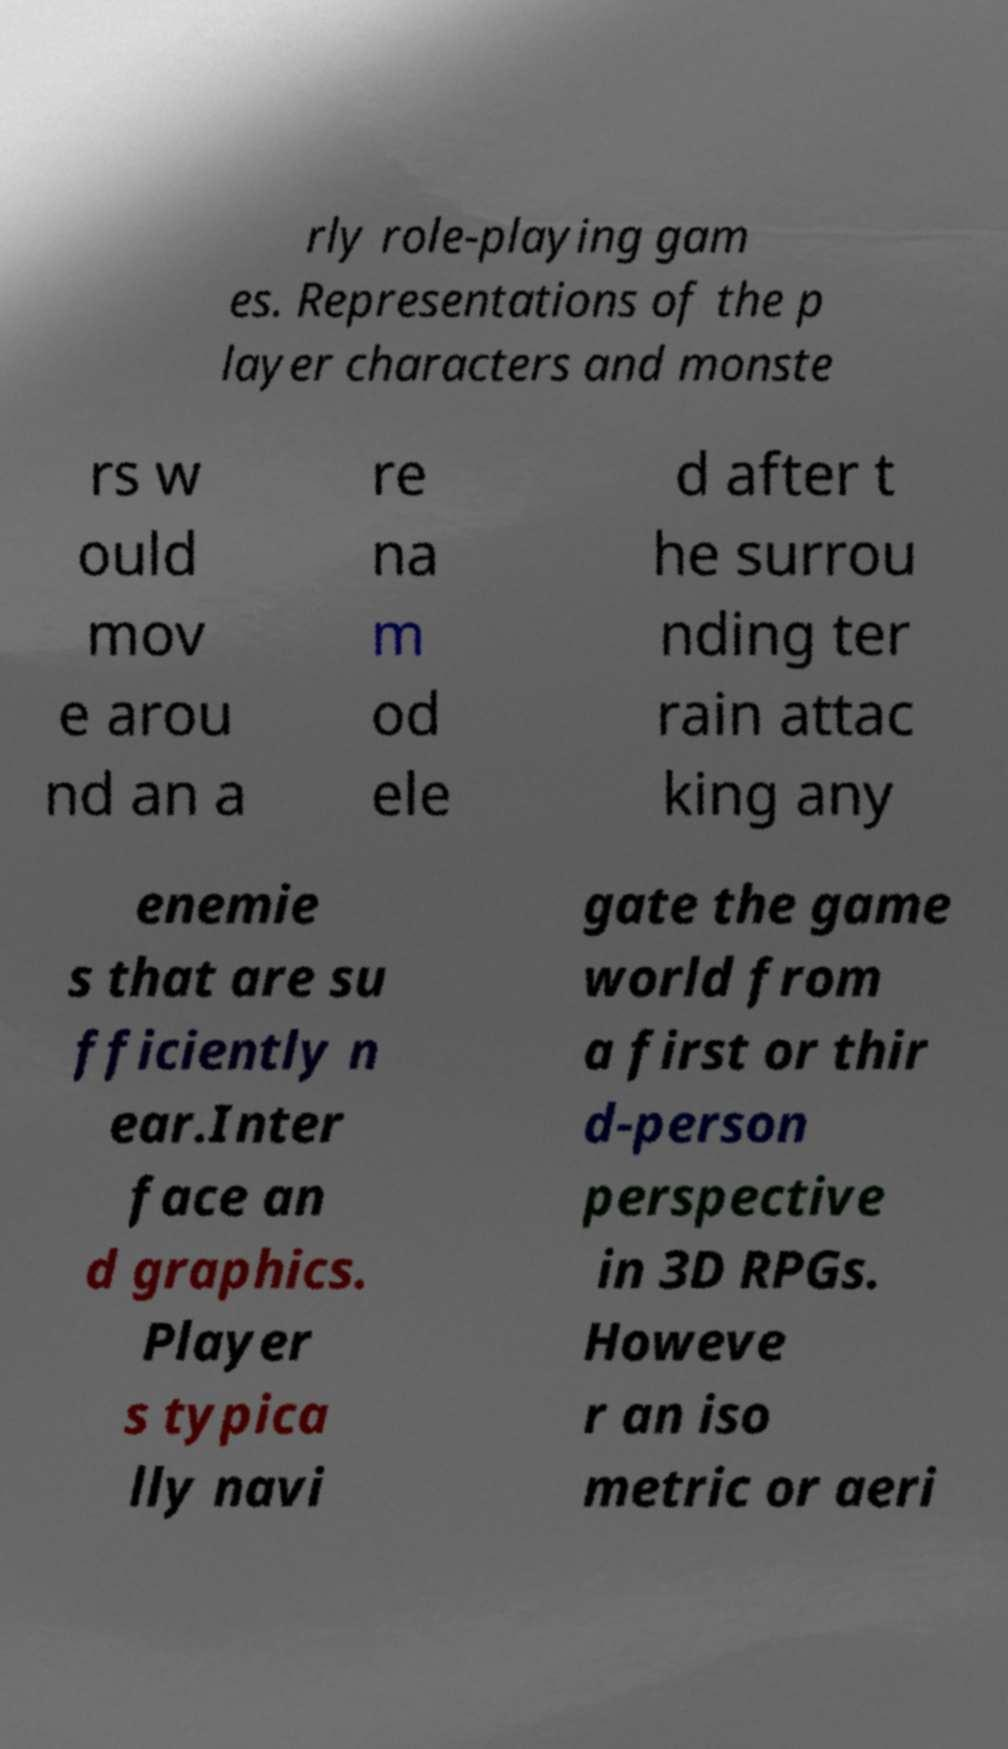Could you extract and type out the text from this image? rly role-playing gam es. Representations of the p layer characters and monste rs w ould mov e arou nd an a re na m od ele d after t he surrou nding ter rain attac king any enemie s that are su fficiently n ear.Inter face an d graphics. Player s typica lly navi gate the game world from a first or thir d-person perspective in 3D RPGs. Howeve r an iso metric or aeri 